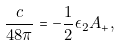<formula> <loc_0><loc_0><loc_500><loc_500>\frac { c } { 4 8 \pi } = - \frac { 1 } { 2 } \epsilon _ { 2 } A _ { + } ,</formula> 